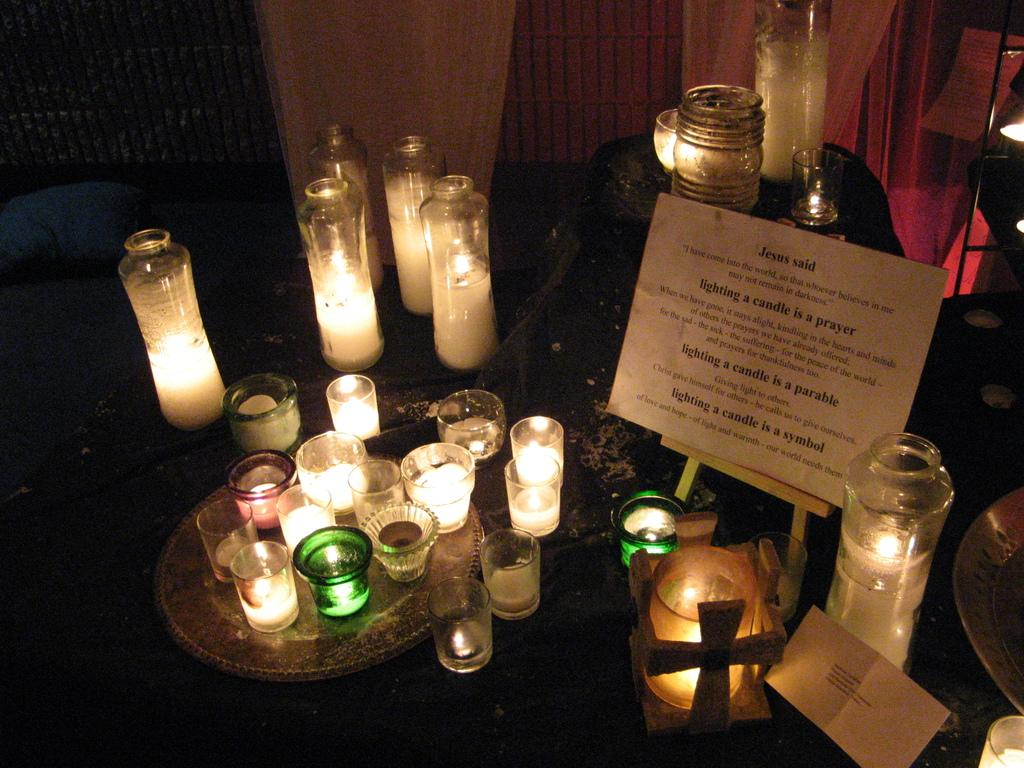What objects can be seen on the surface in the image? There are candles on the surface in the image. What is written or displayed on the board in the image? There is written text on a board in the image. What type of window treatment can be seen in the background of the image? There are curtains visible in the background of the image. Can you tell me how many rifles are present in the image? There are no rifles present in the image; the facts provided do not mention any such objects. 